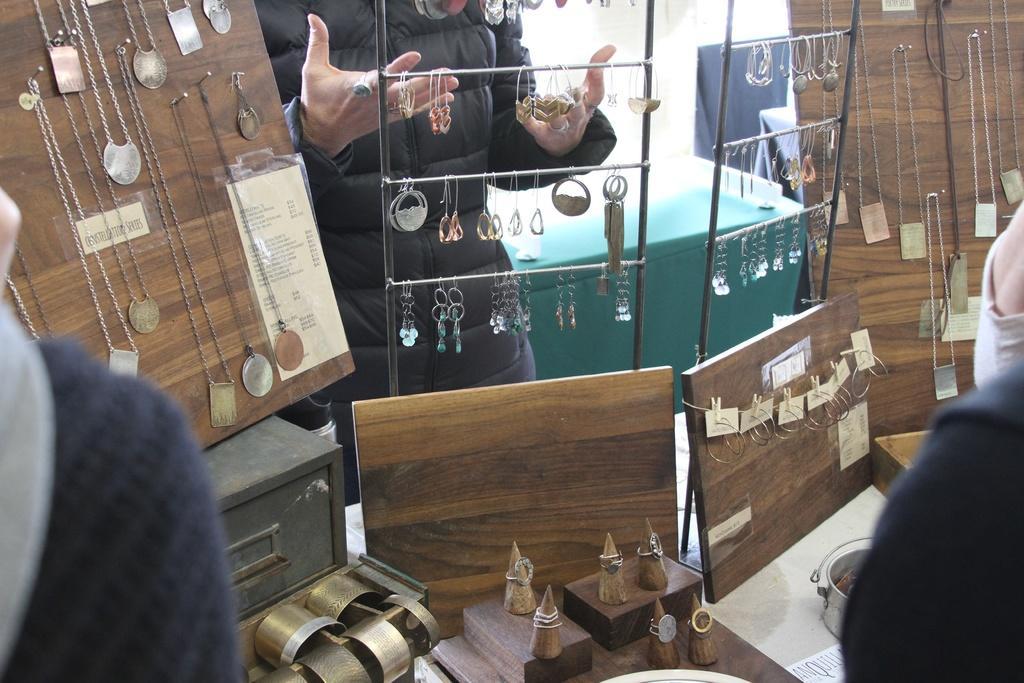In one or two sentences, can you explain what this image depicts? In this picture we can see man standing and holding ear rings in his hands and beside to him we can see chains on board, bangles, some more ear rings and two persons. 